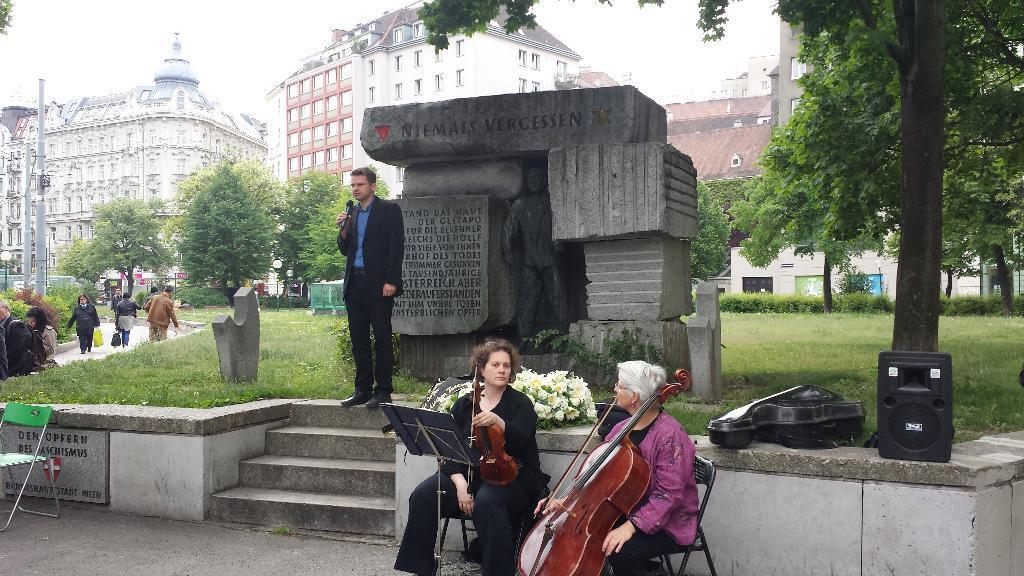Describe this image in one or two sentences. As we can see in the image, there are few people. On the left side there are three people walking on road. In the background there are buildings. On the right side there is a tree and the women who are sitting in the front are holding guitar in there hands. Behind them there is a flower. 